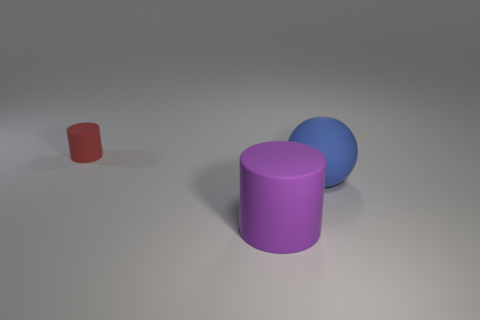Add 1 brown metal cylinders. How many objects exist? 4 Subtract all balls. How many objects are left? 2 Subtract all purple rubber objects. Subtract all gray shiny cubes. How many objects are left? 2 Add 1 small cylinders. How many small cylinders are left? 2 Add 2 blue things. How many blue things exist? 3 Subtract 0 yellow blocks. How many objects are left? 3 